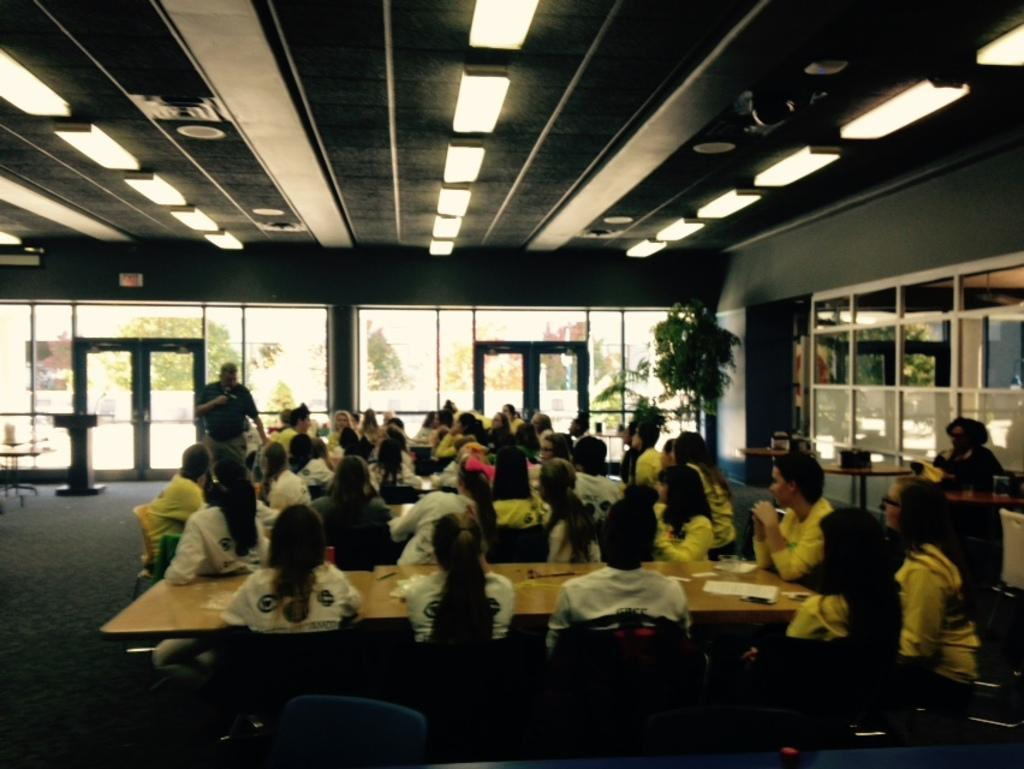What is one of the main objects in the image? There is a door in the image. What are the people in the image doing? The people in the image are sitting on chairs. What piece of furniture is also visible in the image? There is a table in the image. What might be the purpose of the papers on the table? The papers on the table might be used for work or discussion. How many crates are stacked next to the door in the image? There are no crates present in the image. Is there a camp visible in the background of the image? There is no camp visible in the image; it features a door, chairs, a table, and people sitting on the chairs. 